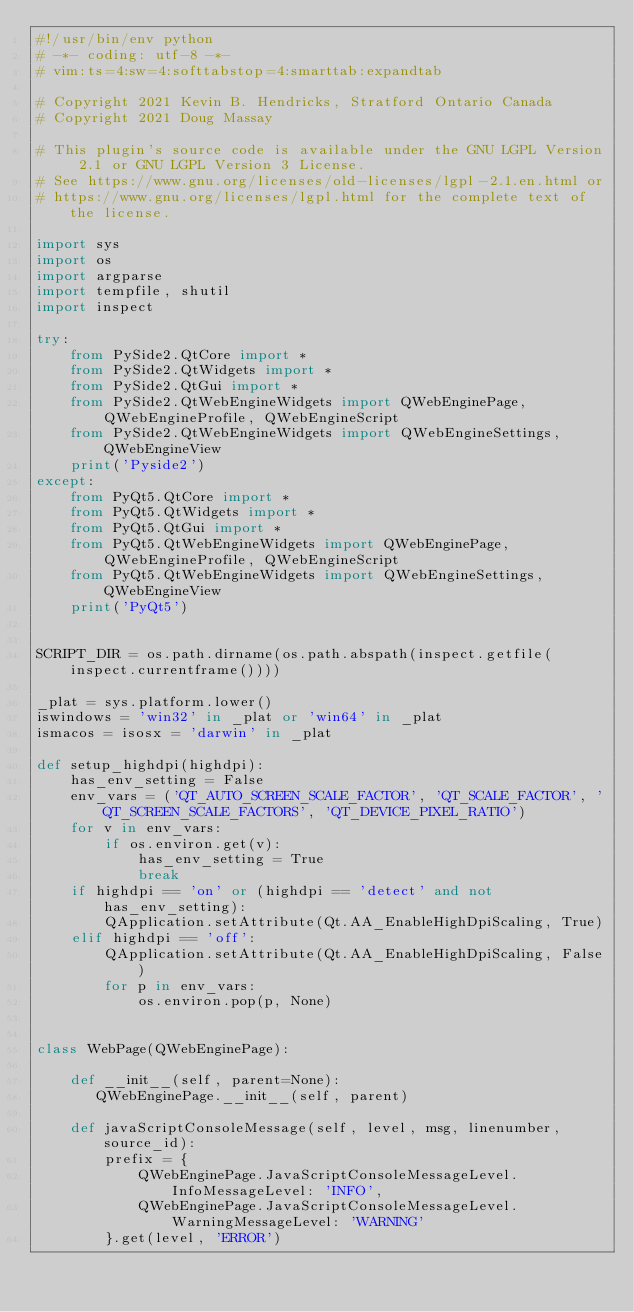Convert code to text. <code><loc_0><loc_0><loc_500><loc_500><_Python_>#!/usr/bin/env python
# -*- coding: utf-8 -*-
# vim:ts=4:sw=4:softtabstop=4:smarttab:expandtab

# Copyright 2021 Kevin B. Hendricks, Stratford Ontario Canada
# Copyright 2021 Doug Massay

# This plugin's source code is available under the GNU LGPL Version 2.1 or GNU LGPL Version 3 License.
# See https://www.gnu.org/licenses/old-licenses/lgpl-2.1.en.html or
# https://www.gnu.org/licenses/lgpl.html for the complete text of the license.

import sys
import os
import argparse
import tempfile, shutil
import inspect

try:
    from PySide2.QtCore import *
    from PySide2.QtWidgets import *
    from PySide2.QtGui import *
    from PySide2.QtWebEngineWidgets import QWebEnginePage, QWebEngineProfile, QWebEngineScript
    from PySide2.QtWebEngineWidgets import QWebEngineSettings, QWebEngineView
    print('Pyside2')
except:
    from PyQt5.QtCore import *
    from PyQt5.QtWidgets import *
    from PyQt5.QtGui import *
    from PyQt5.QtWebEngineWidgets import QWebEnginePage, QWebEngineProfile, QWebEngineScript
    from PyQt5.QtWebEngineWidgets import QWebEngineSettings, QWebEngineView
    print('PyQt5')


SCRIPT_DIR = os.path.dirname(os.path.abspath(inspect.getfile(inspect.currentframe())))

_plat = sys.platform.lower()
iswindows = 'win32' in _plat or 'win64' in _plat
ismacos = isosx = 'darwin' in _plat

def setup_highdpi(highdpi):
    has_env_setting = False
    env_vars = ('QT_AUTO_SCREEN_SCALE_FACTOR', 'QT_SCALE_FACTOR', 'QT_SCREEN_SCALE_FACTORS', 'QT_DEVICE_PIXEL_RATIO')
    for v in env_vars:
        if os.environ.get(v):
            has_env_setting = True
            break
    if highdpi == 'on' or (highdpi == 'detect' and not has_env_setting):
        QApplication.setAttribute(Qt.AA_EnableHighDpiScaling, True)
    elif highdpi == 'off':
        QApplication.setAttribute(Qt.AA_EnableHighDpiScaling, False)
        for p in env_vars:
            os.environ.pop(p, None)


class WebPage(QWebEnginePage):

    def __init__(self, parent=None):
       QWebEnginePage.__init__(self, parent)

    def javaScriptConsoleMessage(self, level, msg, linenumber, source_id):
        prefix = {
            QWebEnginePage.JavaScriptConsoleMessageLevel.InfoMessageLevel: 'INFO',
            QWebEnginePage.JavaScriptConsoleMessageLevel.WarningMessageLevel: 'WARNING'
        }.get(level, 'ERROR')</code> 